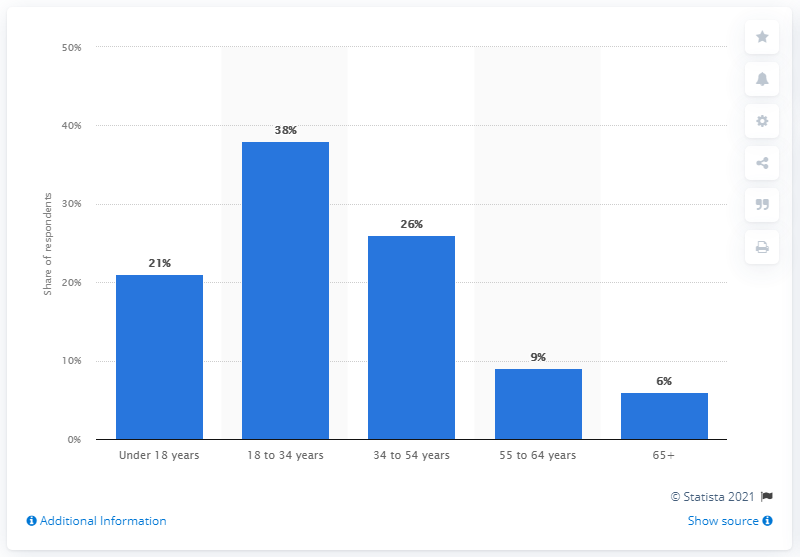Give some essential details in this illustration. The 65+ age group is represented by the rightmost bar. The sum of the lowest two responses from respondents is 15. 